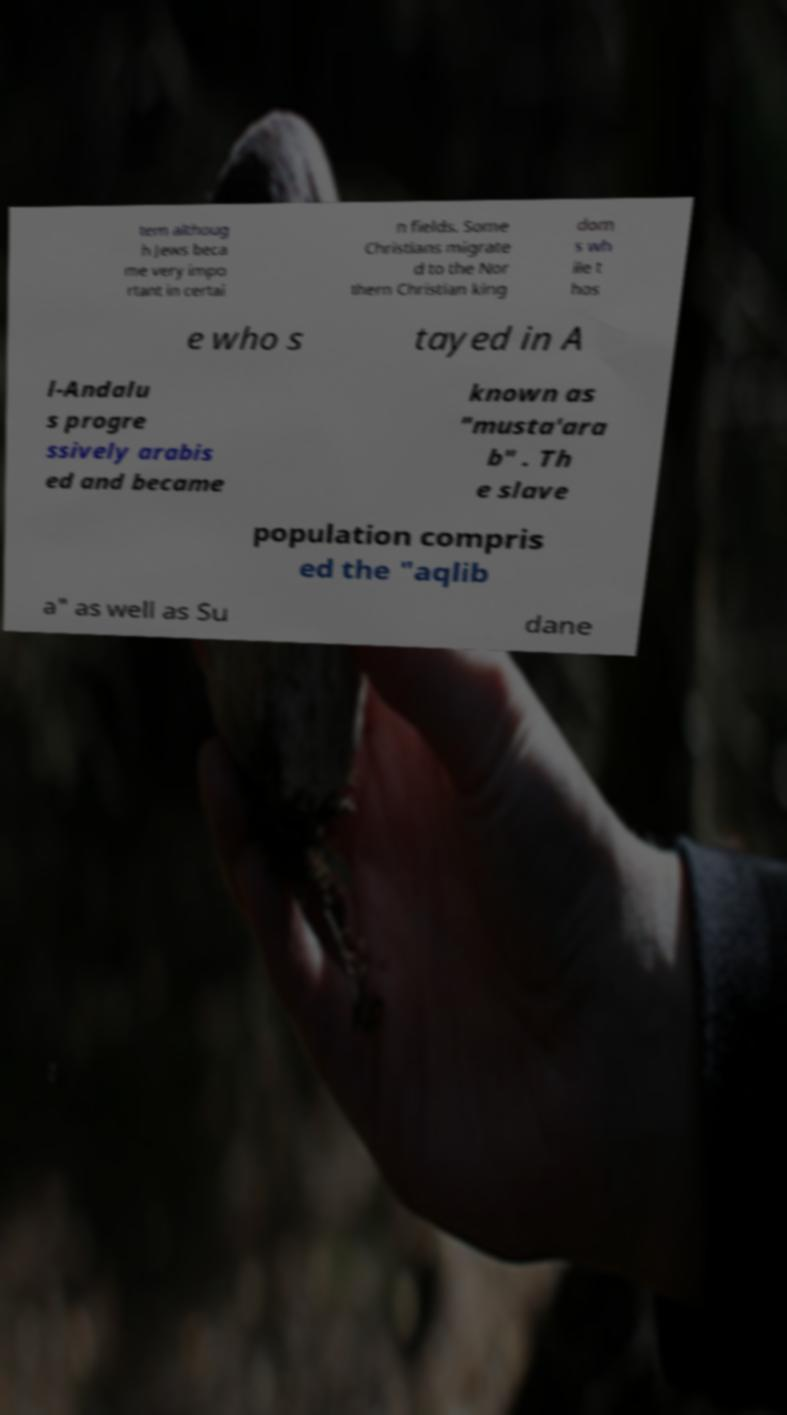Please identify and transcribe the text found in this image. tem althoug h Jews beca me very impo rtant in certai n fields. Some Christians migrate d to the Nor thern Christian king dom s wh ile t hos e who s tayed in A l-Andalu s progre ssively arabis ed and became known as "musta'ara b" . Th e slave population compris ed the "aqlib a" as well as Su dane 